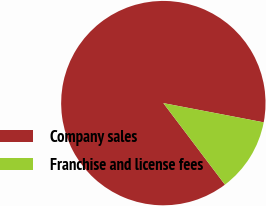Convert chart. <chart><loc_0><loc_0><loc_500><loc_500><pie_chart><fcel>Company sales<fcel>Franchise and license fees<nl><fcel>88.31%<fcel>11.69%<nl></chart> 